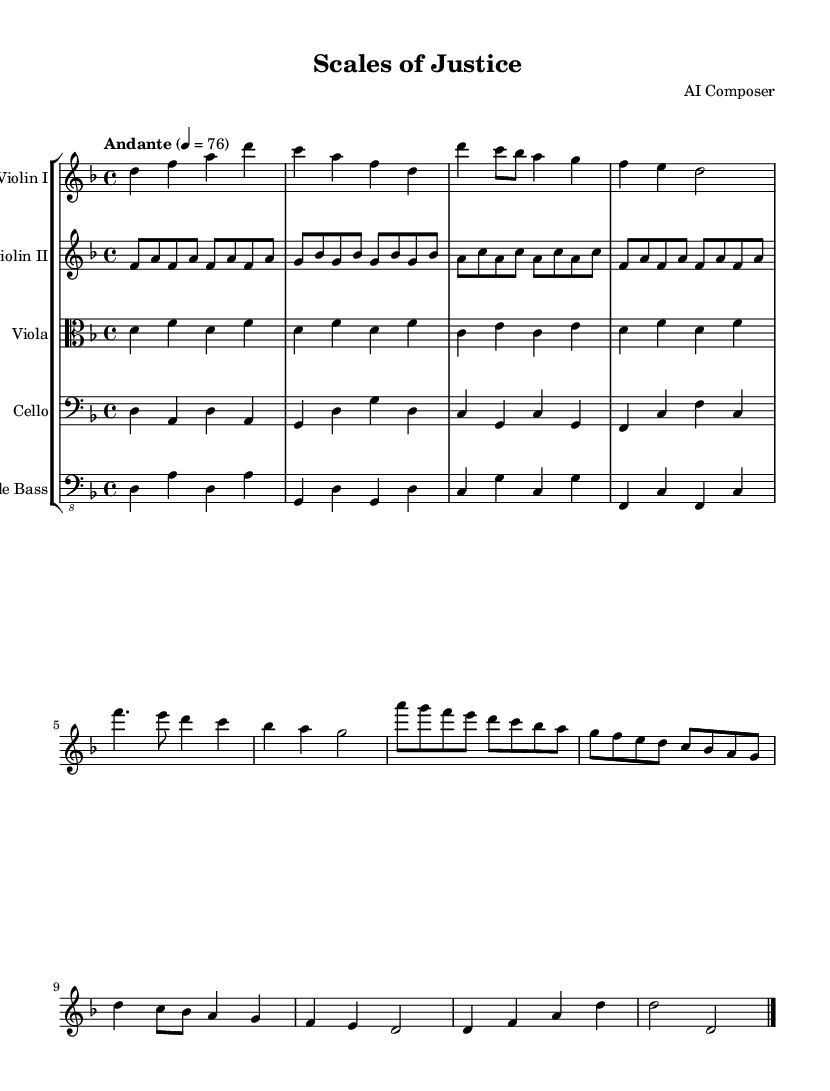What is the key signature of this music? The key signature is D minor, which is indicated by one flat (B flat) in the key signature.
Answer: D minor What is the time signature of this composition? The time signature is 4/4, which allows for four beats per measure, as noted at the beginning of the music.
Answer: 4/4 What is the tempo marking of the piece? The tempo marking is "Andante," which suggests a moderate pace, indicated clearly in the score above the staff.
Answer: Andante How many measures are in the Introduction section? The Introduction section contains two measures, identifiable as the first two measures of the score before Theme A begins.
Answer: 2 Which instrument carries the main melodic theme? The main melodic theme is primarily carried by the Violin I part, which features the most prominent and recognizable melody throughout the piece.
Answer: Violin I How does the Development section differ from the Recapitulation in terms of thematic material? The Development section introduces variations of the themes presented earlier, while the Recapitulation restates the original themes in their initial form, providing structural coherence to the composition.
Answer: Variations What is the final chord of the composition? The final chord is D major, closing the piece with a strong resolution characteristic of classical compositions.
Answer: D major 